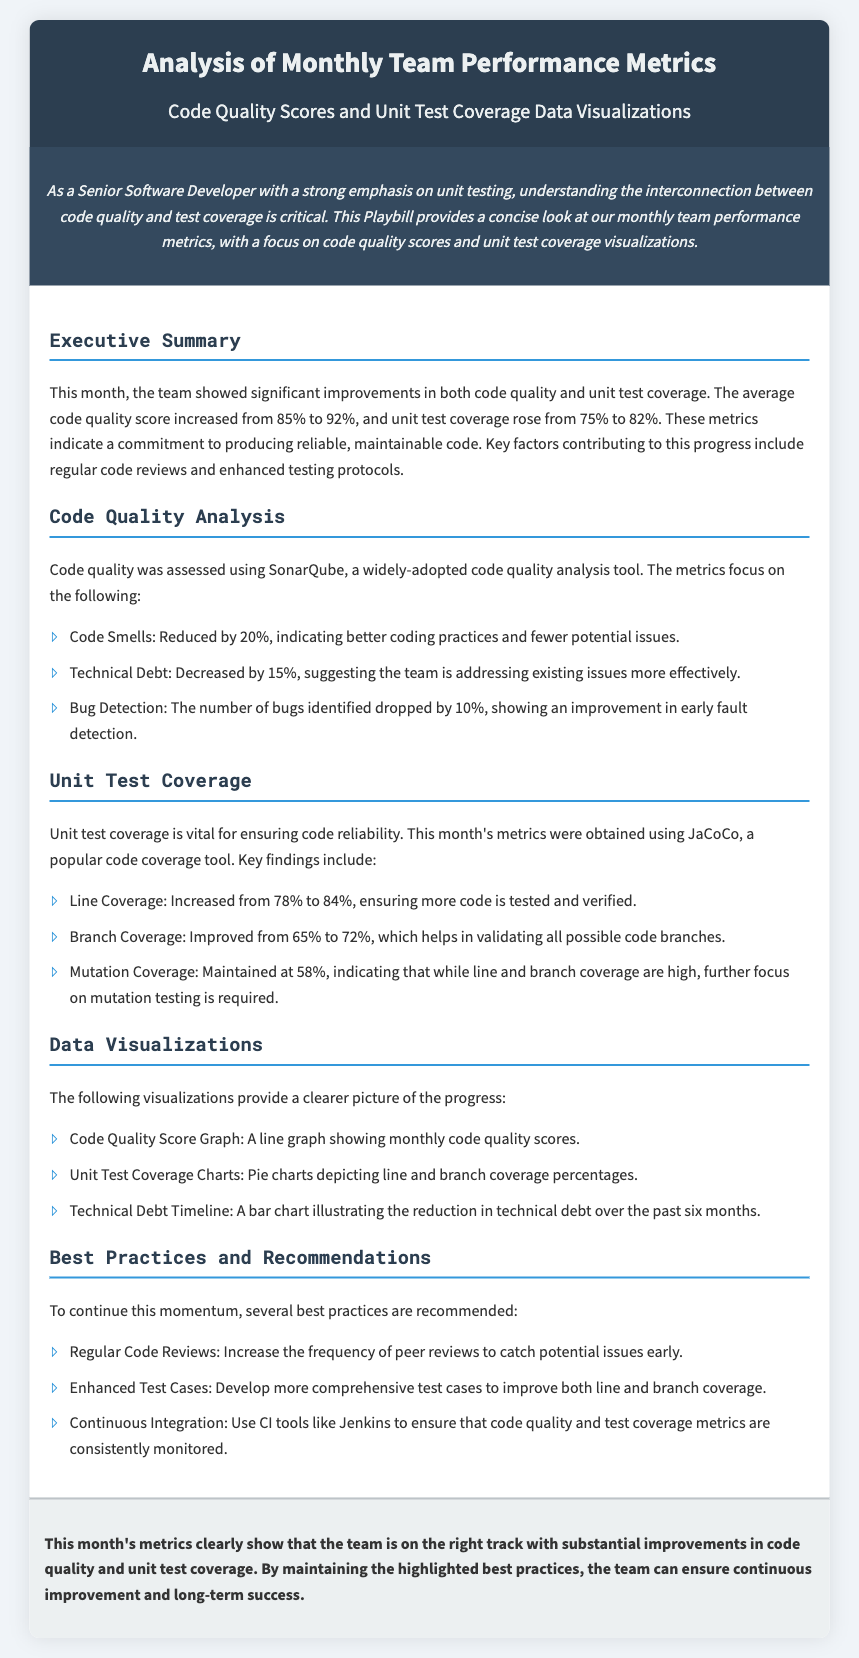What was the average code quality score this month? The average code quality score increased from 85% to 92%.
Answer: 92% What is the percentage increase in unit test coverage? Unit test coverage rose from 75% to 82%, which indicates a 7% increase.
Answer: 7% Which tool was used for code quality analysis? Code quality was assessed using SonarQube.
Answer: SonarQube What was the reduction percentage of code smells? Code Smells reduced by 20%.
Answer: 20% What is the current line coverage percentage? Line Coverage increased from 78% to 84%.
Answer: 84% What best practice is recommended to improve coverage? Develop more comprehensive test cases.
Answer: Test Cases What is the mutation coverage percentage maintained at? Mutation Coverage maintained at 58%.
Answer: 58% What was the decrease in technical debt? Technical Debt decreased by 15%.
Answer: 15% Which CI tool is suggested for monitoring metrics? CI tools like Jenkins are suggested.
Answer: Jenkins 